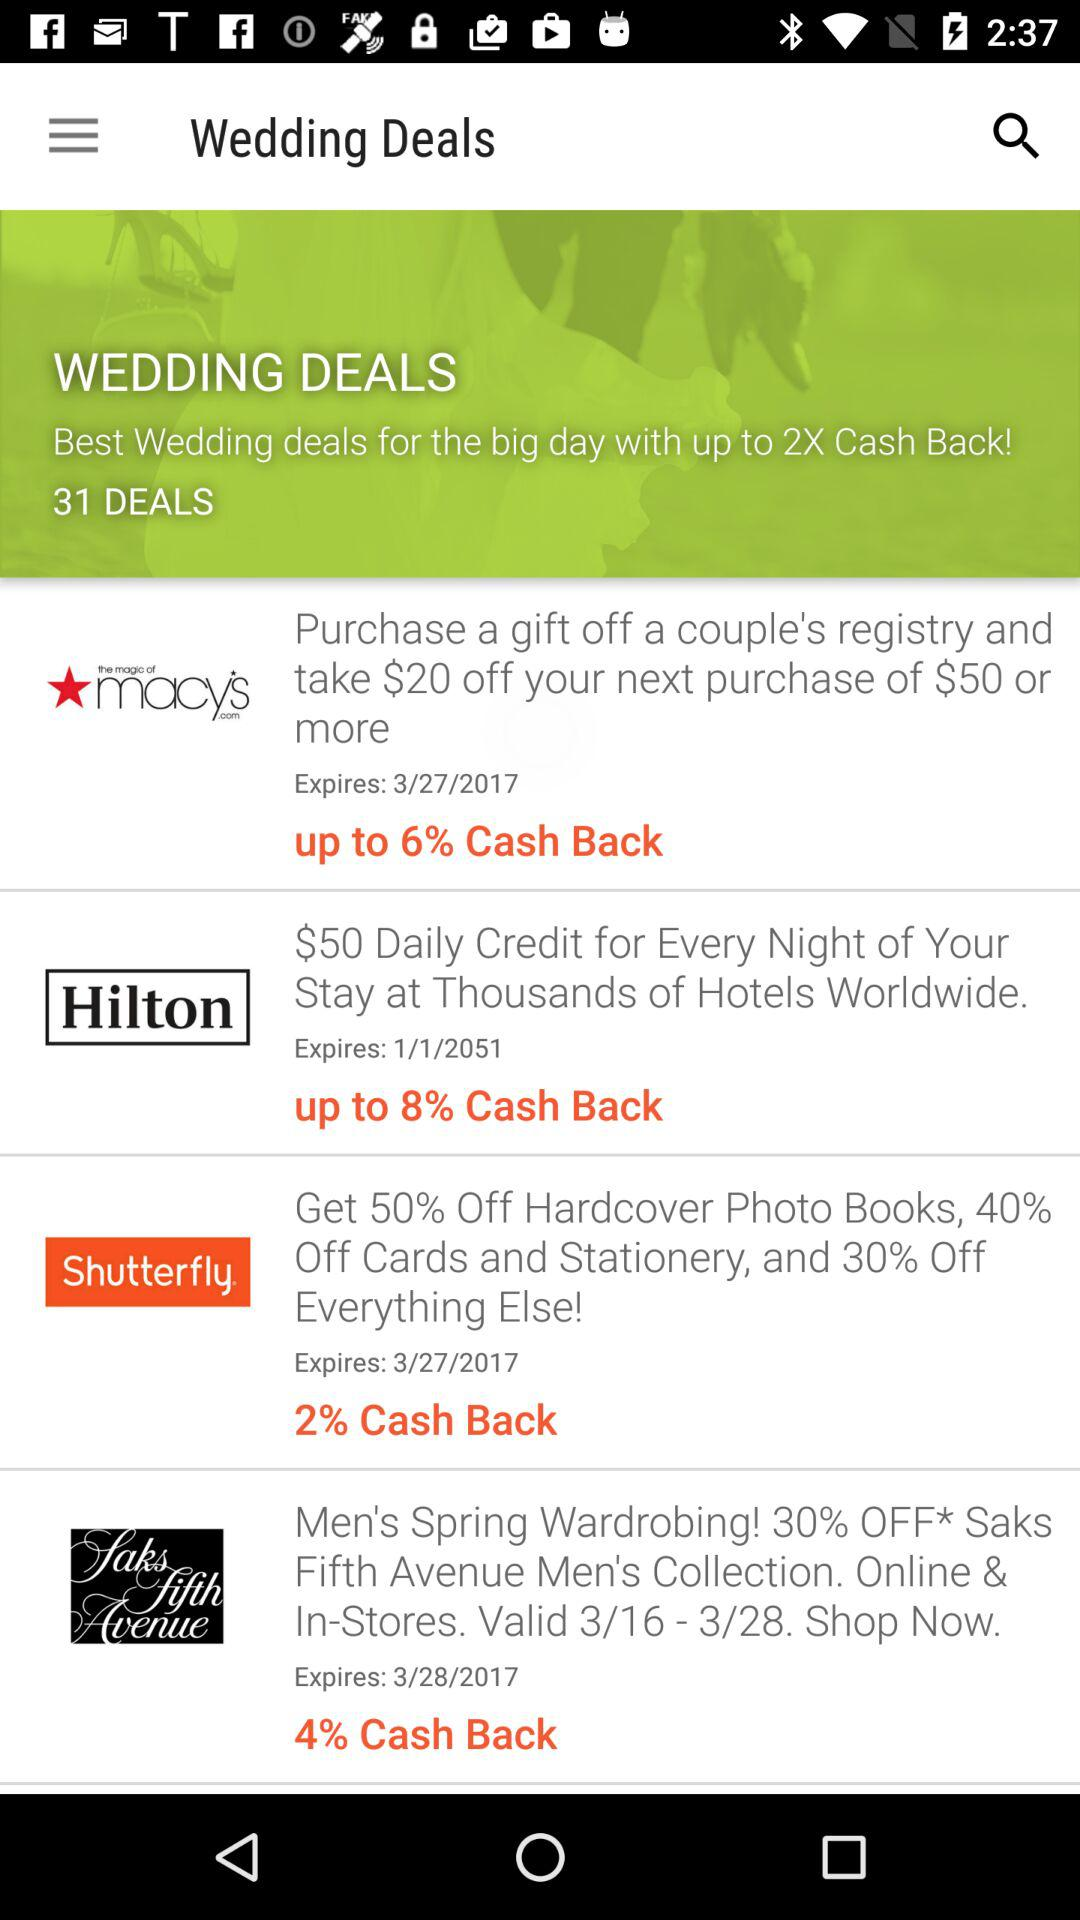When will the deal for Hilton expire? The coupon will expire on January 1, 2051. 